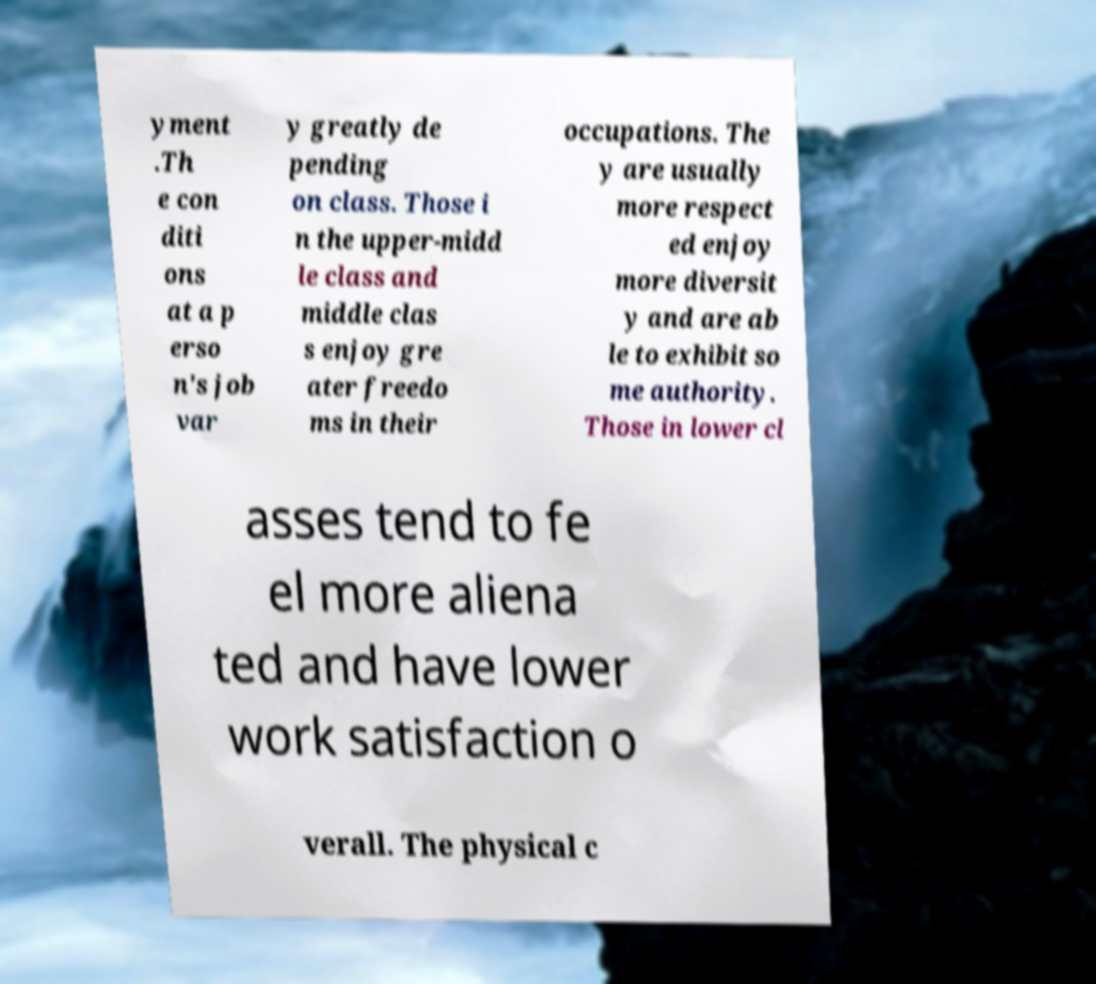Could you extract and type out the text from this image? yment .Th e con diti ons at a p erso n's job var y greatly de pending on class. Those i n the upper-midd le class and middle clas s enjoy gre ater freedo ms in their occupations. The y are usually more respect ed enjoy more diversit y and are ab le to exhibit so me authority. Those in lower cl asses tend to fe el more aliena ted and have lower work satisfaction o verall. The physical c 